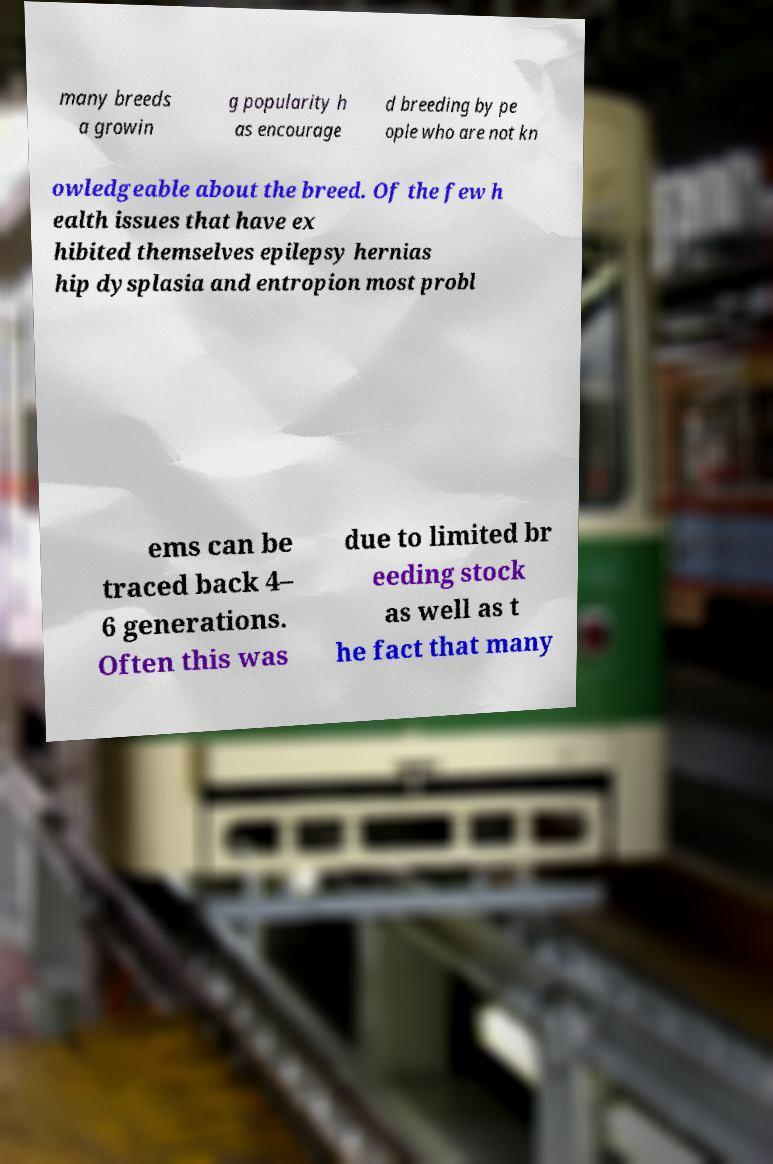Please identify and transcribe the text found in this image. many breeds a growin g popularity h as encourage d breeding by pe ople who are not kn owledgeable about the breed. Of the few h ealth issues that have ex hibited themselves epilepsy hernias hip dysplasia and entropion most probl ems can be traced back 4– 6 generations. Often this was due to limited br eeding stock as well as t he fact that many 